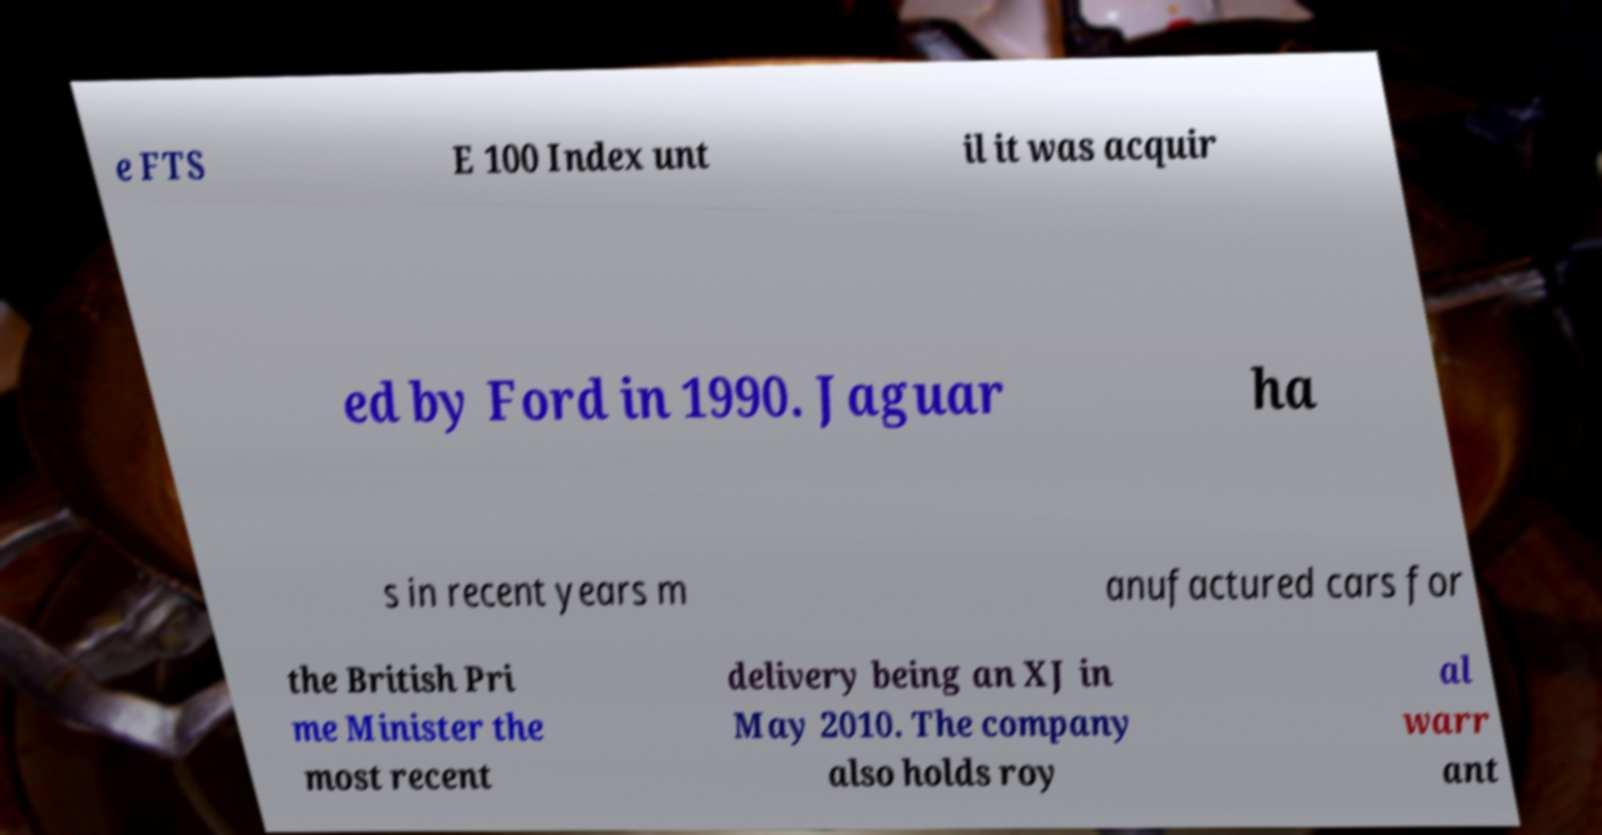I need the written content from this picture converted into text. Can you do that? e FTS E 100 Index unt il it was acquir ed by Ford in 1990. Jaguar ha s in recent years m anufactured cars for the British Pri me Minister the most recent delivery being an XJ in May 2010. The company also holds roy al warr ant 